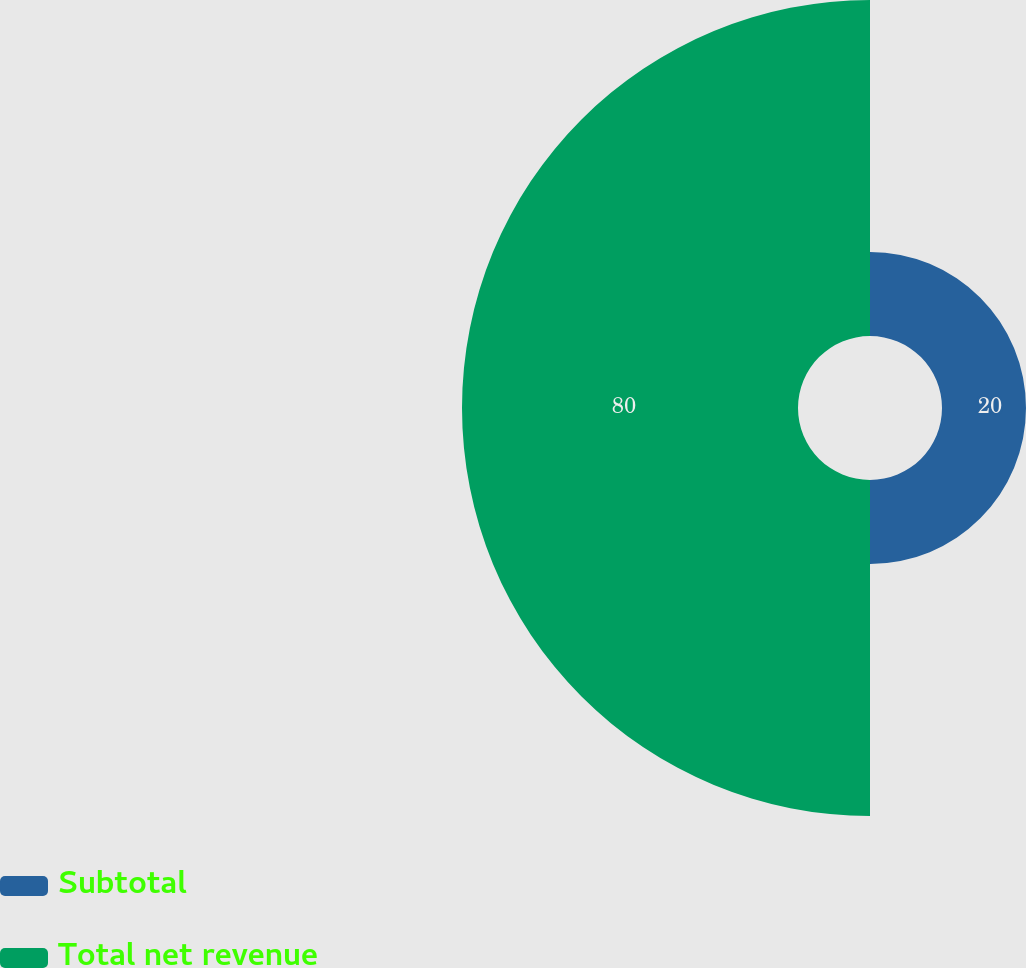<chart> <loc_0><loc_0><loc_500><loc_500><pie_chart><fcel>Subtotal<fcel>Total net revenue<nl><fcel>20.0%<fcel>80.0%<nl></chart> 